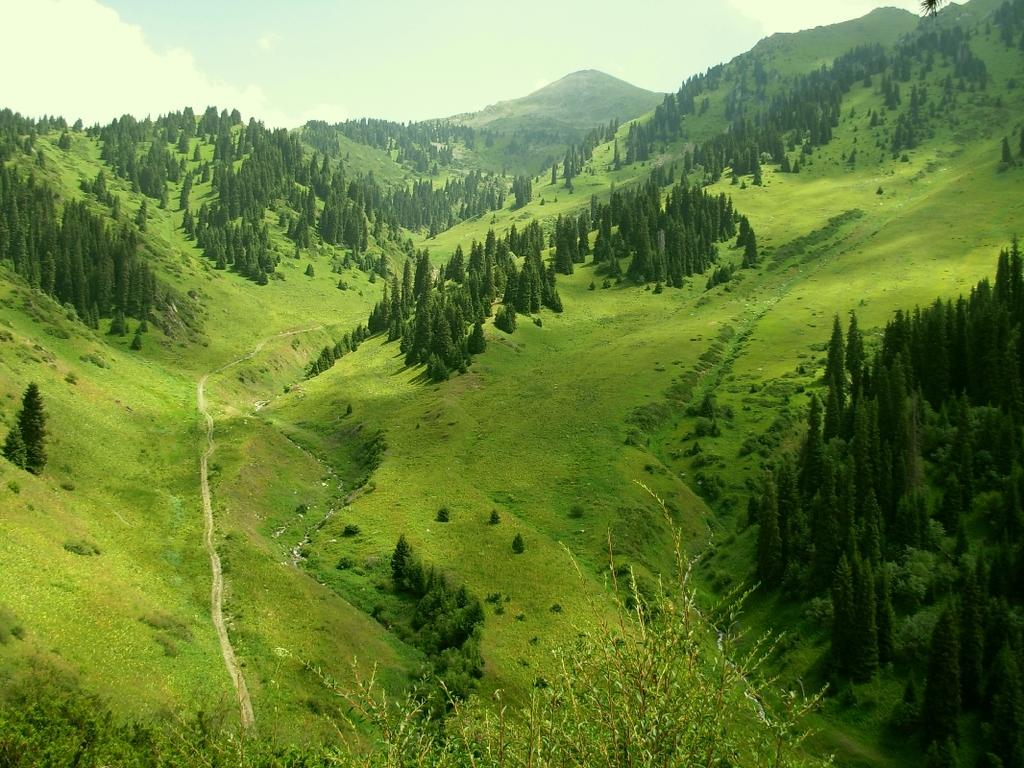What type of natural formation is visible in the image? There are mountains in the image. What is the appearance of the mountains? The mountains are covered with grass and have trees. What is visible in the sky in the image? The sky is covered with clouds. What type of toe can be seen on the mountain in the image? There are no toes present in the image; it features mountains covered with grass and trees. What level of difficulty is associated with climbing the mountain in the image? The image does not provide information about the difficulty level of climbing the mountain. 